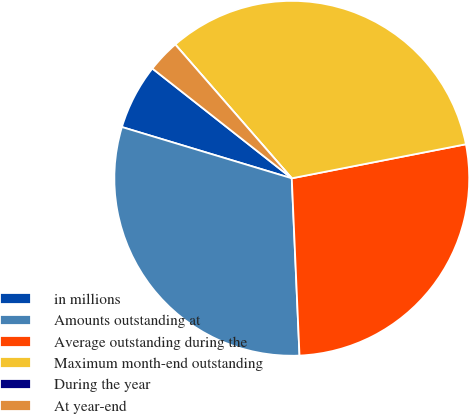Convert chart. <chart><loc_0><loc_0><loc_500><loc_500><pie_chart><fcel>in millions<fcel>Amounts outstanding at<fcel>Average outstanding during the<fcel>Maximum month-end outstanding<fcel>During the year<fcel>At year-end<nl><fcel>5.95%<fcel>30.36%<fcel>27.38%<fcel>33.33%<fcel>0.0%<fcel>2.98%<nl></chart> 